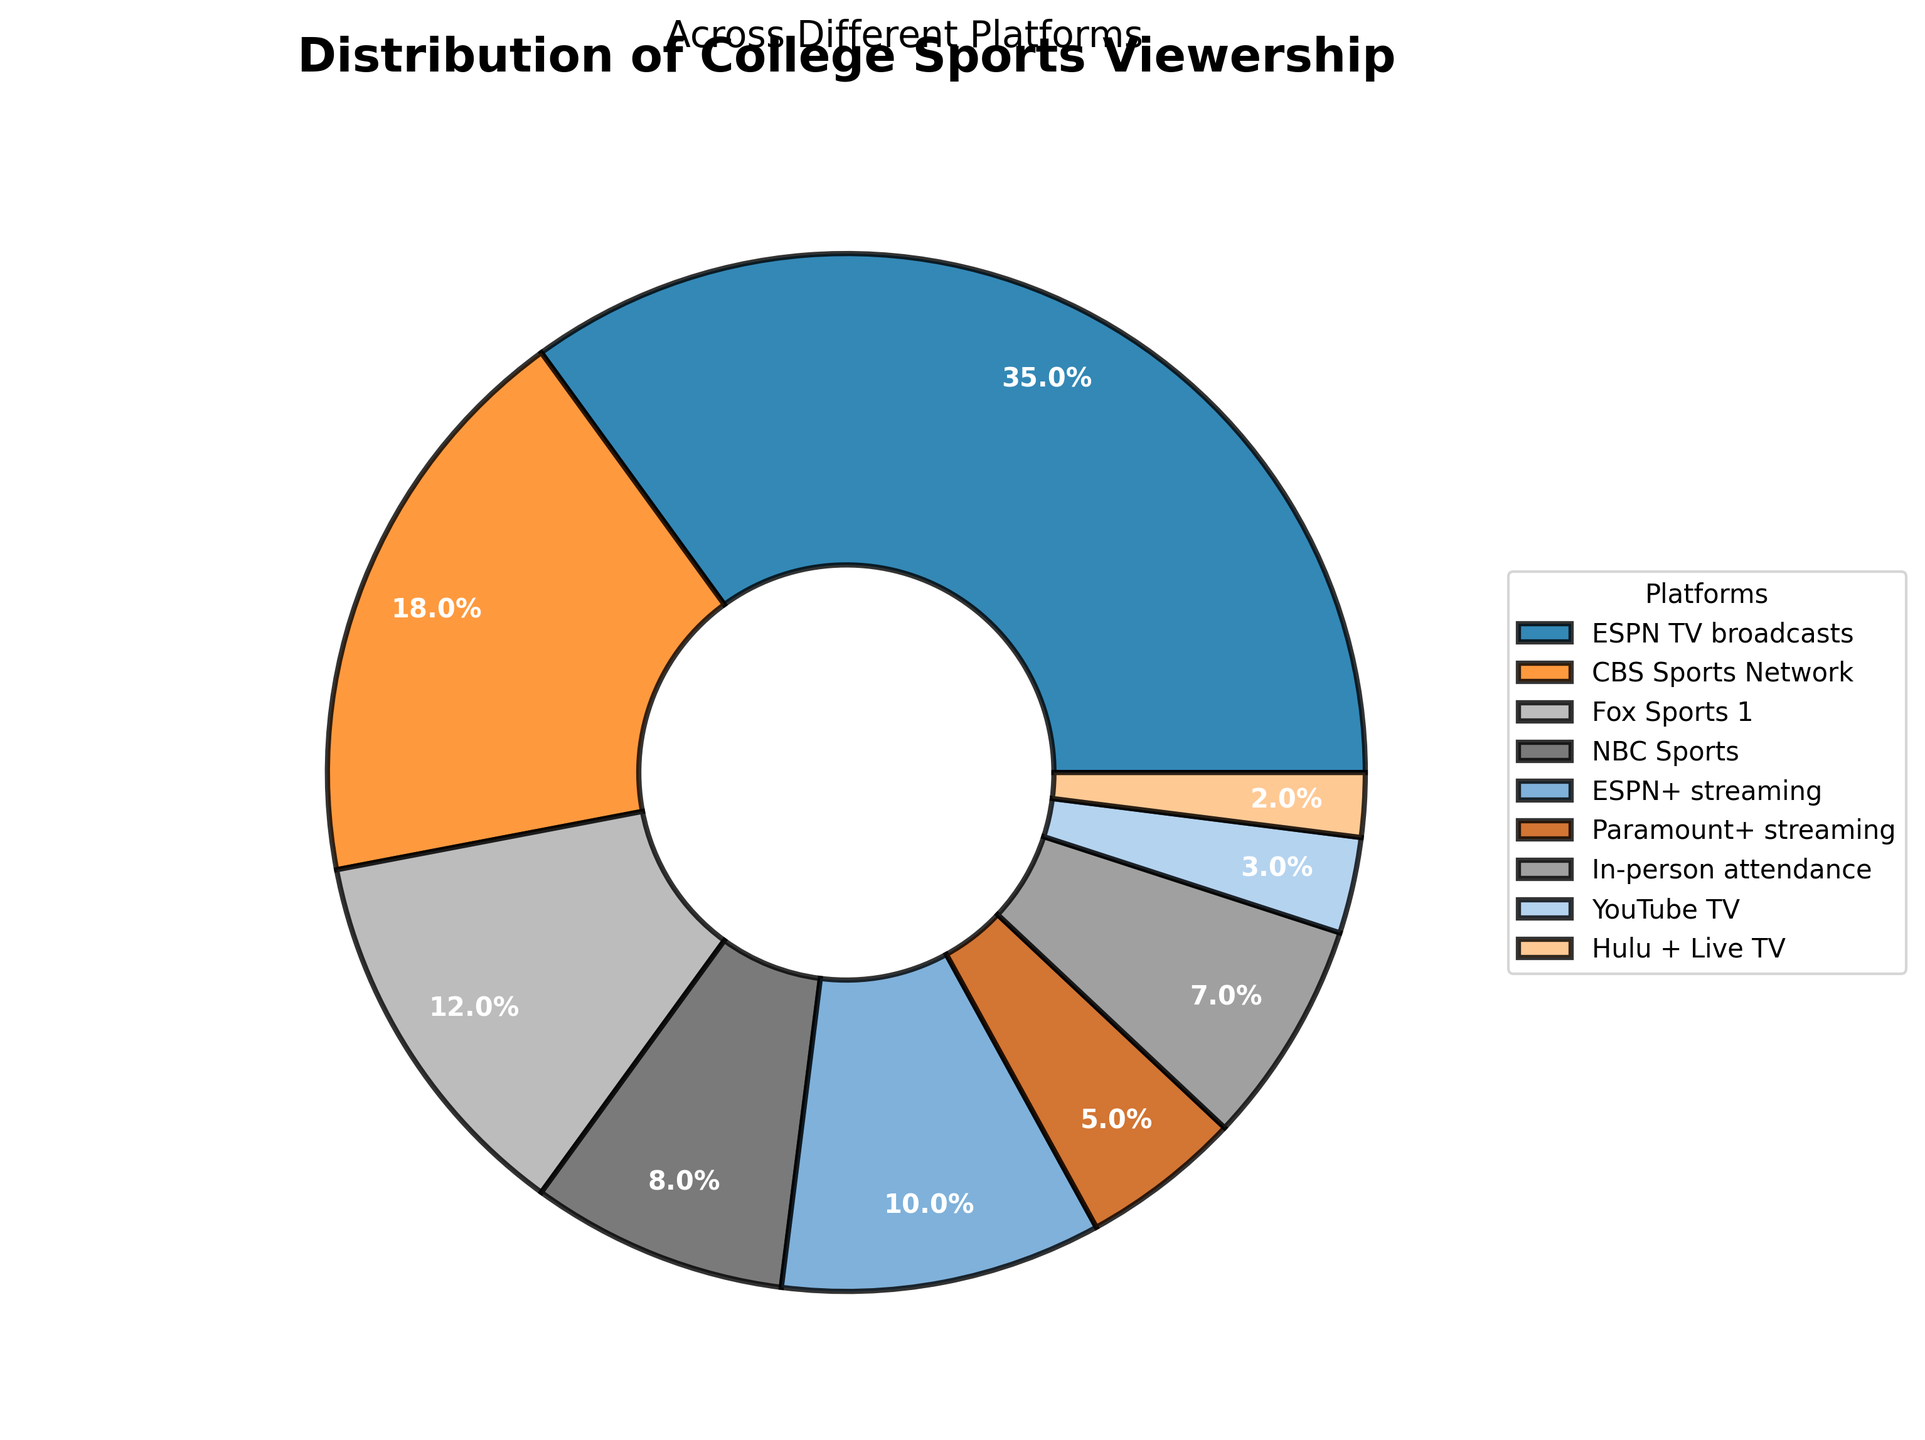What platform has the highest percentage of viewership? By looking at the pie chart, we see that ESPN TV broadcasts have the largest slice of the pie. The label indicates 35%.
Answer: ESPN TV broadcasts What is the combined percentage of CBS Sports Network and Fox Sports 1? The percentage for CBS Sports Network is 18%, and for Fox Sports 1, it is 12%. Adding these together: 18 + 12 = 30%.
Answer: 30% How does NBC Sports' viewership percentage compare to ESPN+ streaming? The pie chart indicates that NBC Sports has an 8% share, while ESPN+ streaming has a 10% share. Since 10% is greater than 8%, ESPN+ streaming has a higher percentage.
Answer: ESPN+ streaming has a higher percentage Which platforms have less than 10% viewership each? List them. Platforms with less than 10% slices in the pie chart are NBC Sports (8%), Paramount+ streaming (5%), In-person attendance (7%), YouTube TV (3%), and Hulu + Live TV (2%).
Answer: NBC Sports, Paramount+ streaming, In-person attendance, YouTube TV, Hulu + Live TV What is the difference in viewership percentage between ESPN TV broadcasts and Fox Sports 1? ESPN TV broadcasts have a 35% share and Fox Sports 1 has a 12% share. The difference is calculated as 35 - 12 = 23%.
Answer: 23% What percentage of viewership comes from streaming platforms? The percentages from streaming platforms are ESPN+ (10%) and Paramount+ (5%). Summing these: 10 + 5 = 15%.
Answer: 15% How does the viewership percentage of CBS Sports Network compare to the total of Hulu + Live TV and YouTube TV? CBS Sports Network has an 18% share. Hulu + Live TV has 2%, and YouTube TV has 3%. Adding them together: 2 + 3 = 5%. CBS Sports Network's share is larger: 18% > 5%.
Answer: CBS Sports Network is larger What is the combined percentage of all platforms, excluding in-person attendance? The total percentage of all platforms including in-person attendance is 100%. Subtracting in-person attendance's 7% gives: 100 - 7 = 93%.
Answer: 93% Is any single streaming service's viewership equal to or higher than in-person attendance? The pie chart shows the largest single streaming service is ESPN+ with 10%, which is higher than in-person attendance at 7%. Paramount+ streaming has a 5% share, which is lower than in-person attendance.
Answer: ESPN+ streaming is higher What's the total percentage shared by YouTube TV, Hulu + Live TV, and Paramount+ streaming? YouTube TV has 3%, Hulu + Live TV has 2%, and Paramount+ streaming has 5%. Adding them together: 3 + 2 + 5 = 10%.
Answer: 10% 